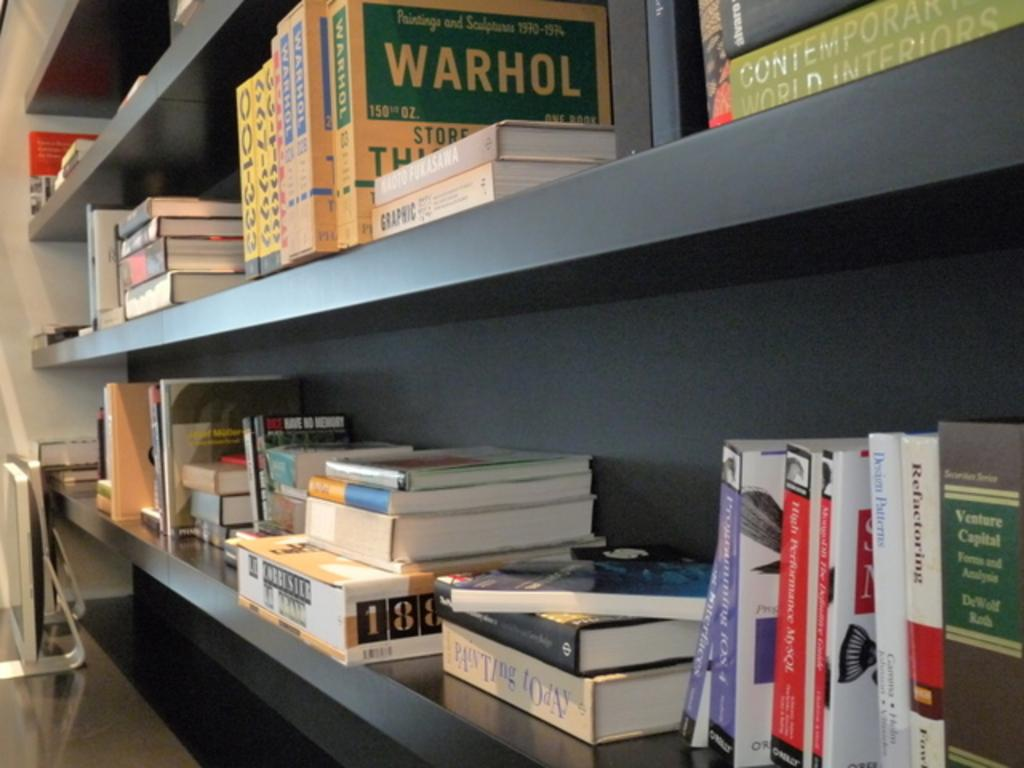<image>
Create a compact narrative representing the image presented. A lot of books on wall shelves, one of which is labeled Warhol. 